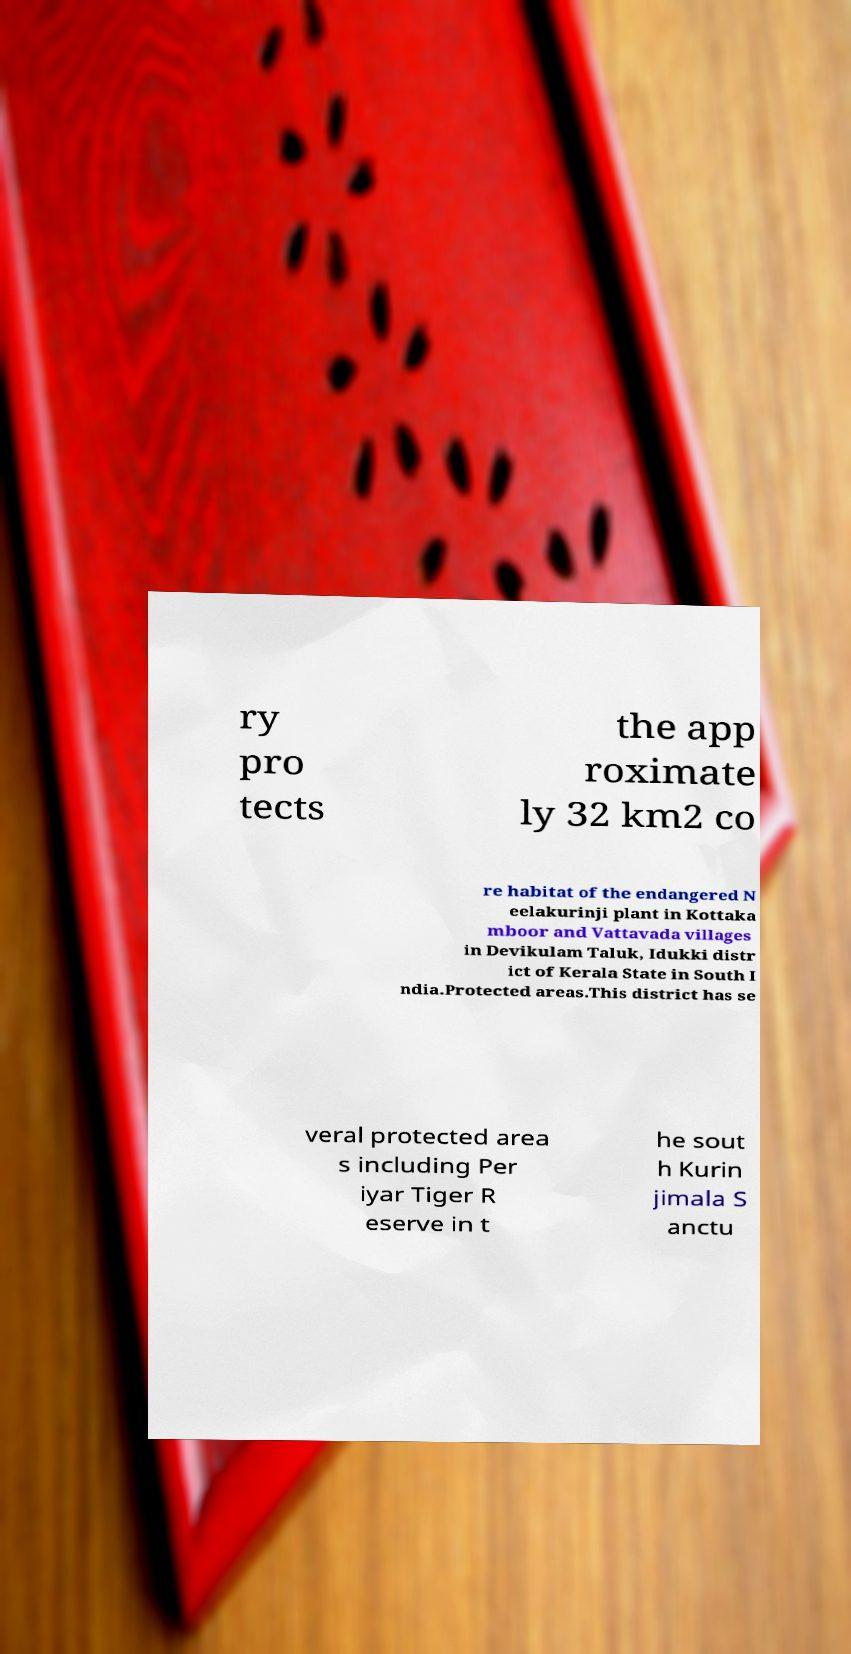Could you assist in decoding the text presented in this image and type it out clearly? ry pro tects the app roximate ly 32 km2 co re habitat of the endangered N eelakurinji plant in Kottaka mboor and Vattavada villages in Devikulam Taluk, Idukki distr ict of Kerala State in South I ndia.Protected areas.This district has se veral protected area s including Per iyar Tiger R eserve in t he sout h Kurin jimala S anctu 